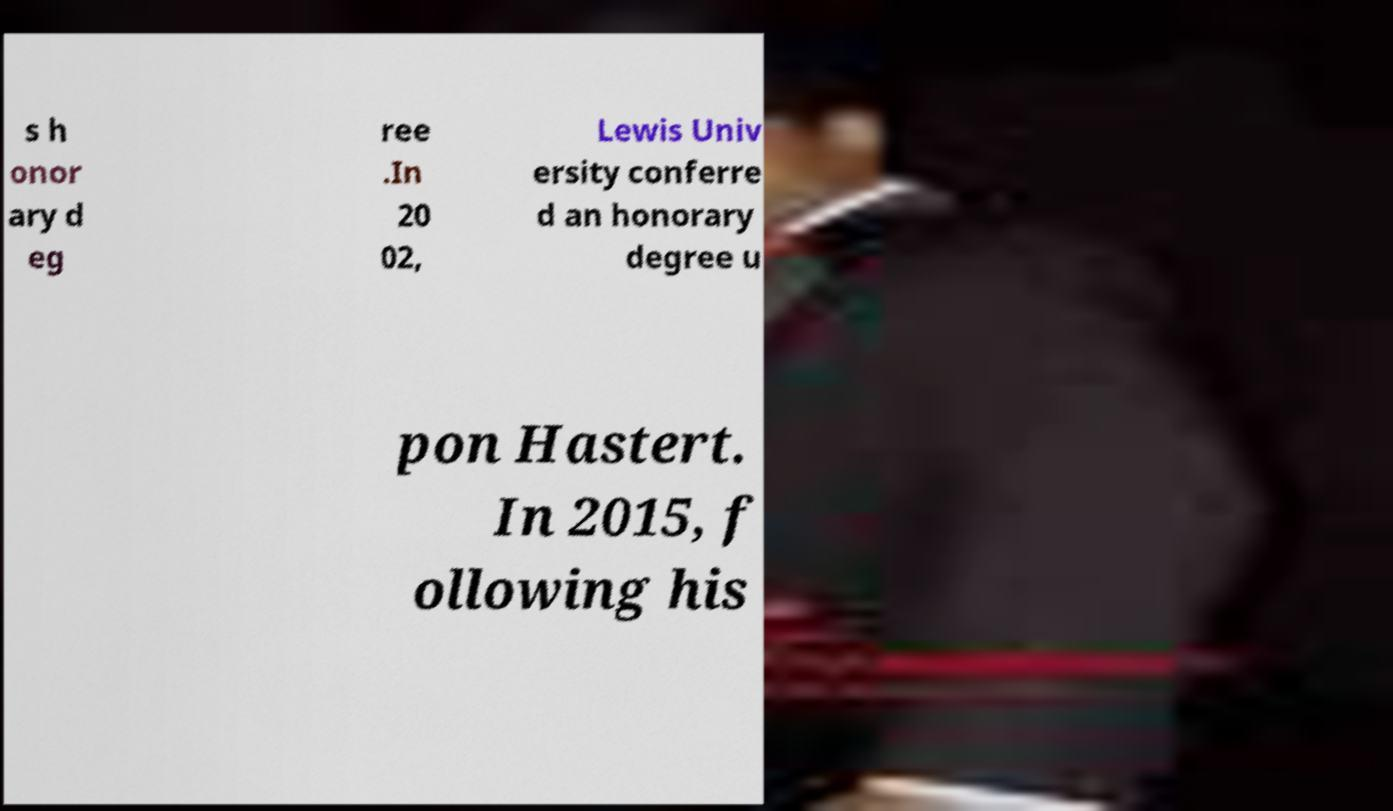Please read and relay the text visible in this image. What does it say? s h onor ary d eg ree .In 20 02, Lewis Univ ersity conferre d an honorary degree u pon Hastert. In 2015, f ollowing his 